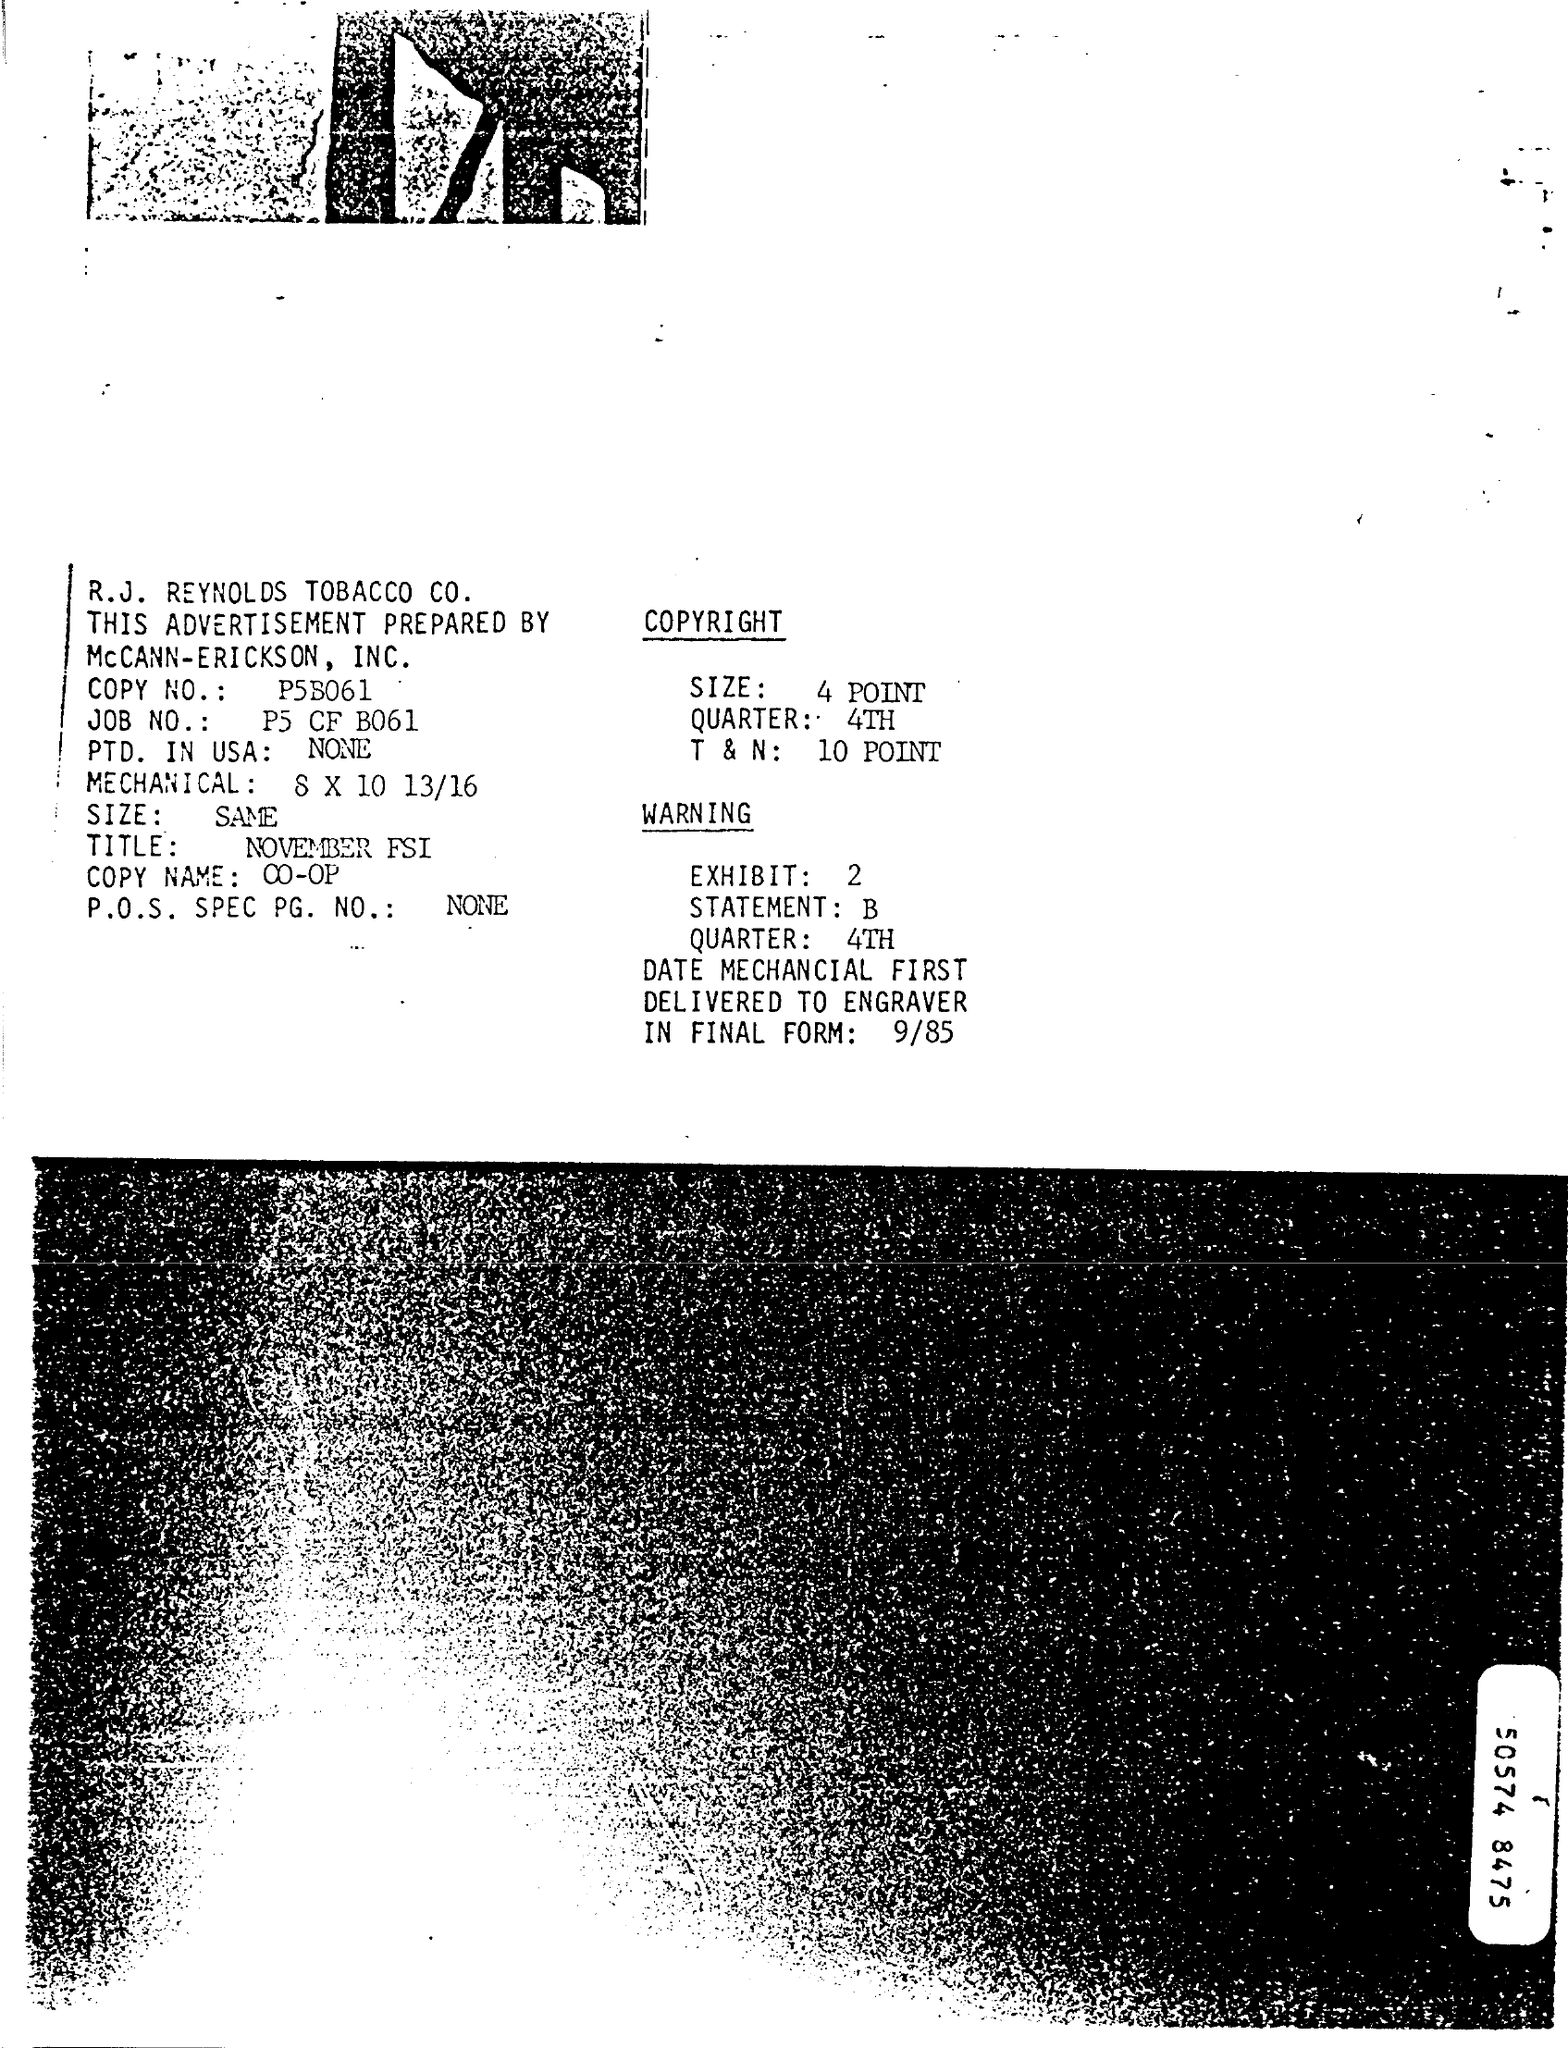What is the name of the company ?
Ensure brevity in your answer.  R.J. Reynolds Tobacco Co. What is the copy no?
Your answer should be very brief. P5b061. What is the job no ?
Make the answer very short. P5 cf b061. What is the title mentioned ?
Ensure brevity in your answer.  NOVEMBER FSI. What is the quarter of the copyright ?
Give a very brief answer. 4TH. How much is the t&n of the copyright
Keep it short and to the point. 10 POINT. What is the exhibit no in warning ?
Offer a very short reply. 2. Which  is the quarter is  mentioned in warning ?
Offer a very short reply. 4th. 